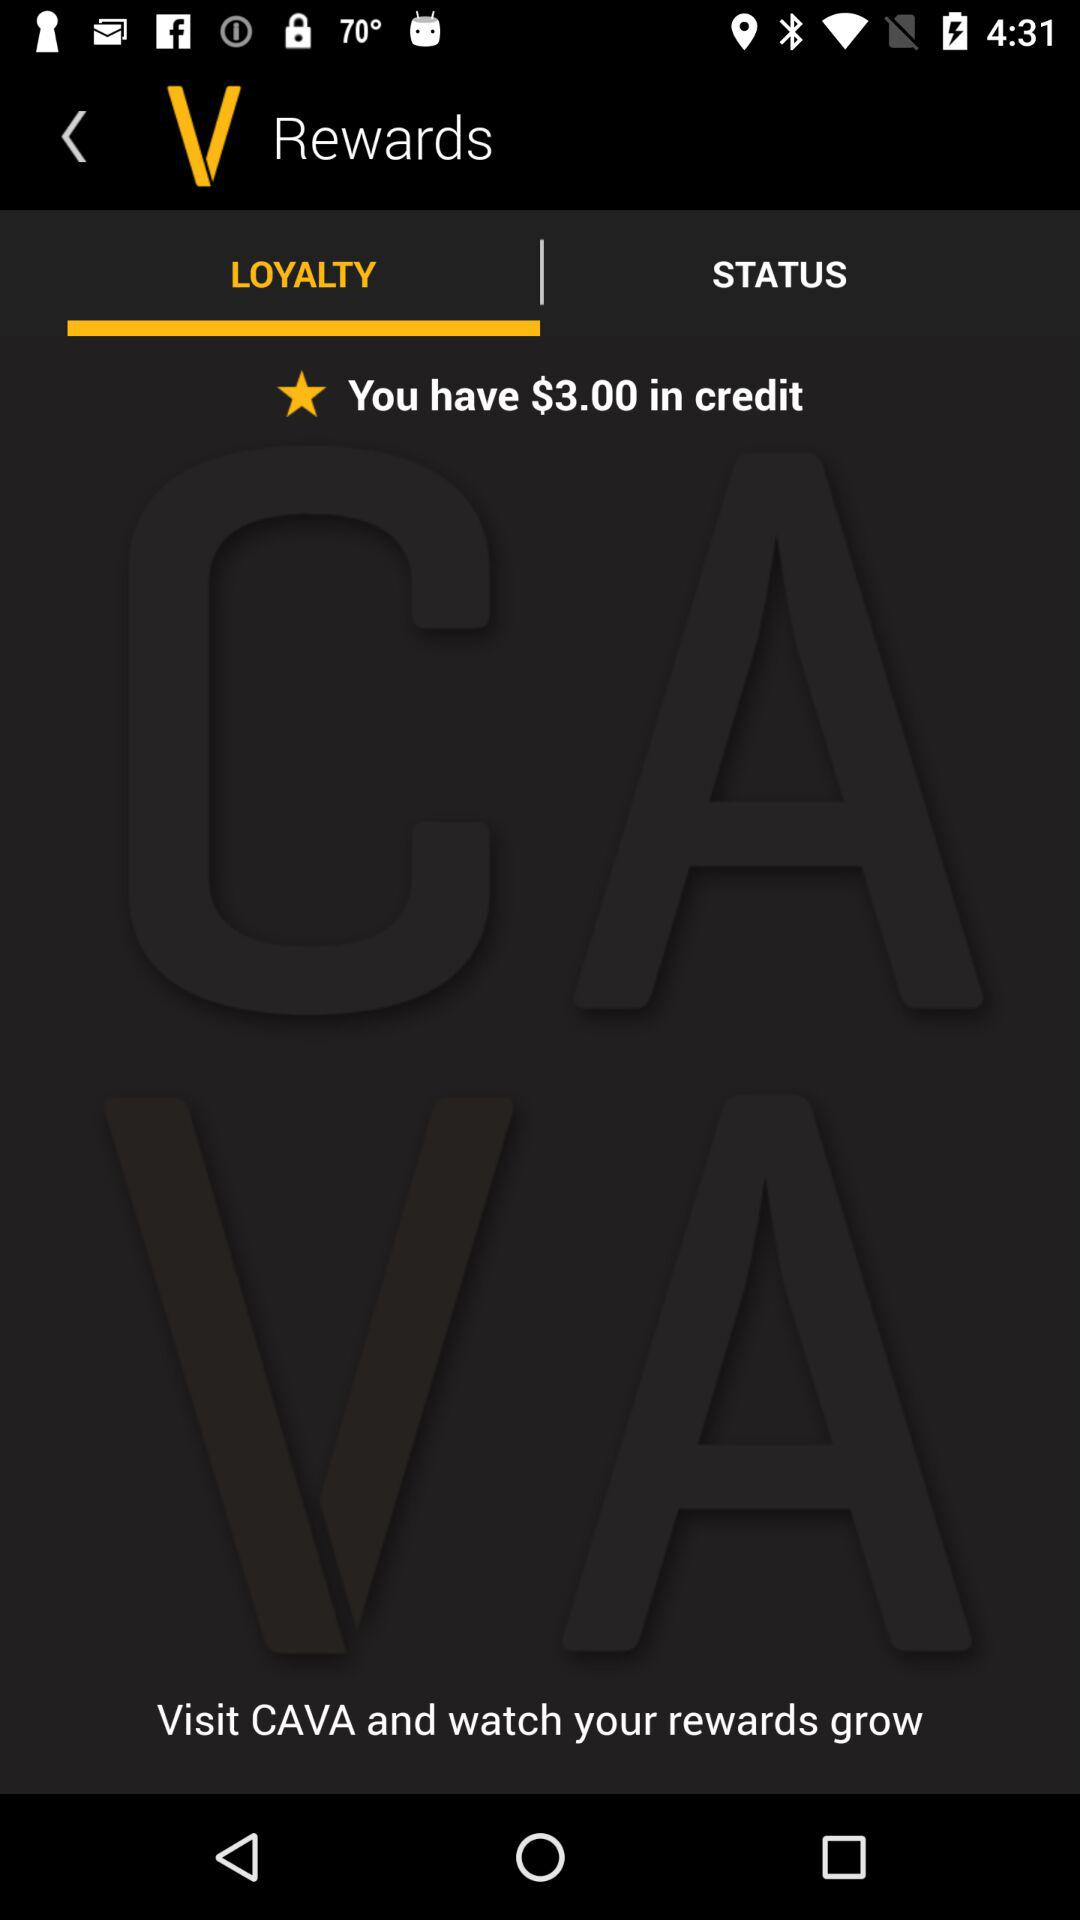What is the application name? The application name is "CAVA". 